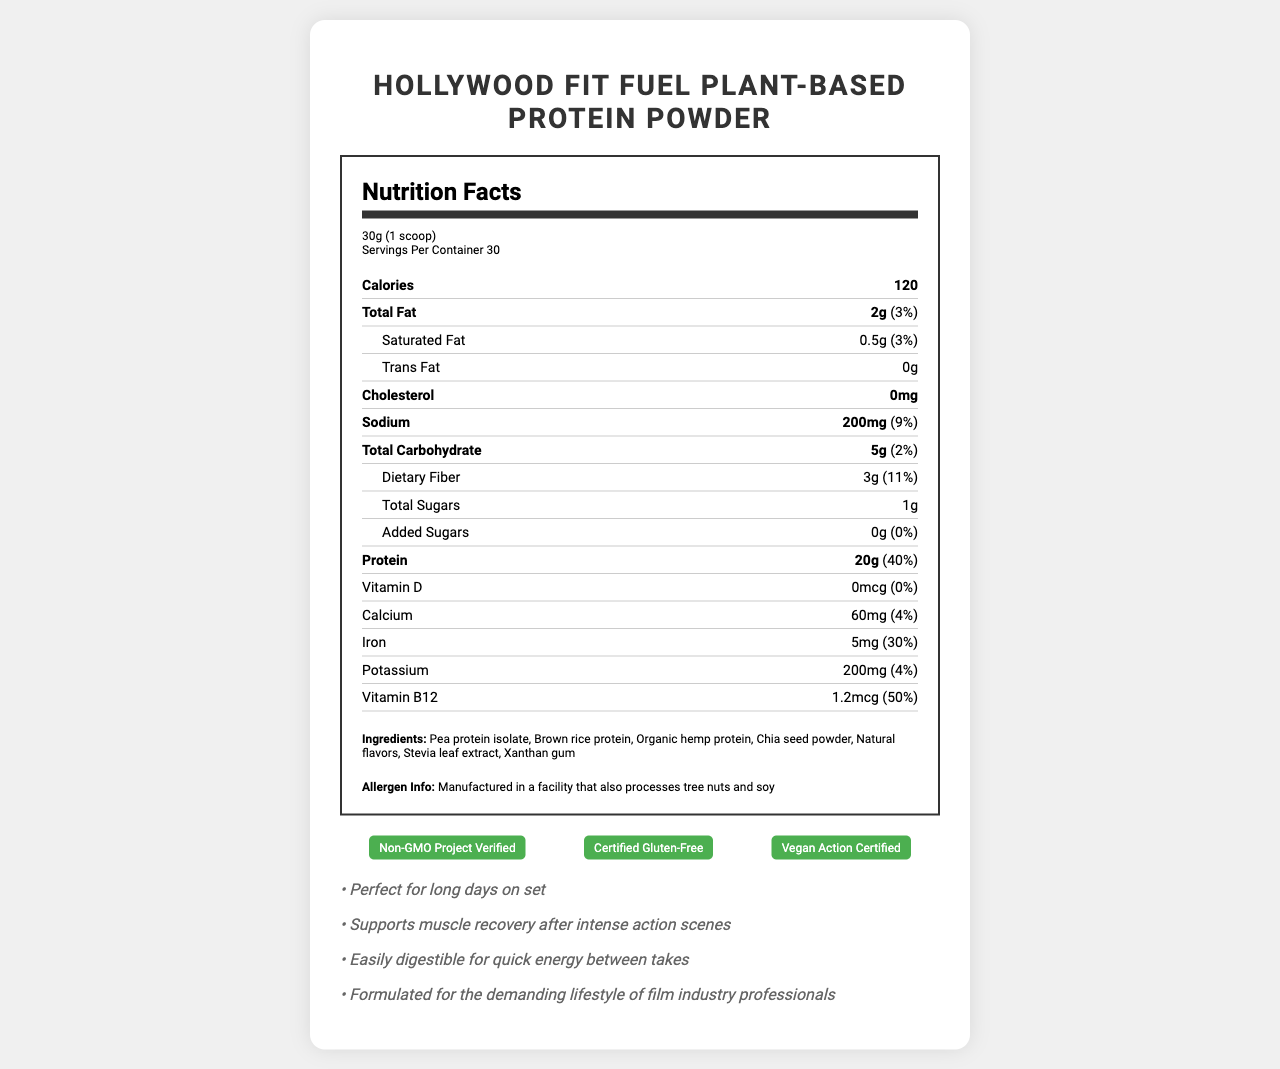what is the serving size for this protein powder? The serving size is stated as "30g (1 scoop)" at the top of the Nutrition Facts section.
Answer: 30g (1 scoop) how many calories are there per serving? The document states that there are 120 calories per serving.
Answer: 120 list the ingredients of the Hollywood Fit Fuel Plant-Based Protein Powder. The ingredients are listed at the bottom of the Nutrition Facts section.
Answer: Pea protein isolate, Brown rice protein, Organic hemp protein, Chia seed powder, Natural flavors, Stevia leaf extract, Xanthan gum how much protein does it contain per serving? The amount of protein per serving is stated as "20g" in the nutrition label.
Answer: 20g does this protein powder contain any added sugars? According to the Nutrition Facts, it contains 0g of added sugars.
Answer: No what is the flavor of the protein powder? A. Chocolate Delight B. Vanilla Bean Blockbuster C. Strawberry Sensation The flavor is listed as Vanilla Bean Blockbuster.
Answer: B which of the following certifications does the protein powder have? A. Organic Certified B. Non-GMO Project Verified C. Certified Gluten-Free D. Vegan Action Certified The certifications listed are Non-GMO Project Verified, Certified Gluten-Free, and Vegan Action Certified.
Answer: B, C, D what is the amount of dietary fiber per serving? The document lists dietary fiber as 3g per serving.
Answer: 3g is this product suitable for vegans? The product is listed as Vegan Action Certified, indicating it is suitable for vegans.
Answer: Yes does this product contain any cholesterol? The document states that there is 0mg of cholesterol.
Answer: No are there any allergens noted in the document? The product is manufactured in a facility that also processes tree nuts and soy.
Answer: Yes summarize the main idea of the document. The explanation contains elements such as serving size, nutritional value, ingredients, allergen info, certifications, and marketing claims that are relevant to understanding the overall content of the document.
Answer: The document provides detailed nutrition facts and additional information about Hollywood Fit Fuel Plant-Based Protein Powder, a plant-based, gluten-free protein supplement designed for health-conscious actors and crew members. The label includes nutritional data, ingredient list, allergen information, certifications, and marketing claims. what type of protein is used in the product? The document lists the sources of protein (pea protein isolate, brown rice protein, organic hemp protein), but doesn't specify the type in a direct categorial form.
Answer: Cannot be determined how much vitamin B12 is in each serving? The document lists vitamin B12 at 1.2mcg per serving and mentions it fulfills 50% of the daily value.
Answer: 1.2mcg what does the marketing claim highlight about the product? The marketing claims highlight benefits such as supporting muscle recovery, being easily digestible for quick energy, and being suited for the intense demands of those working in the film industry.
Answer: It supports muscle recovery and provides quick energy, indicating it is formulated for the demanding lifestyle of film industry professionals. 